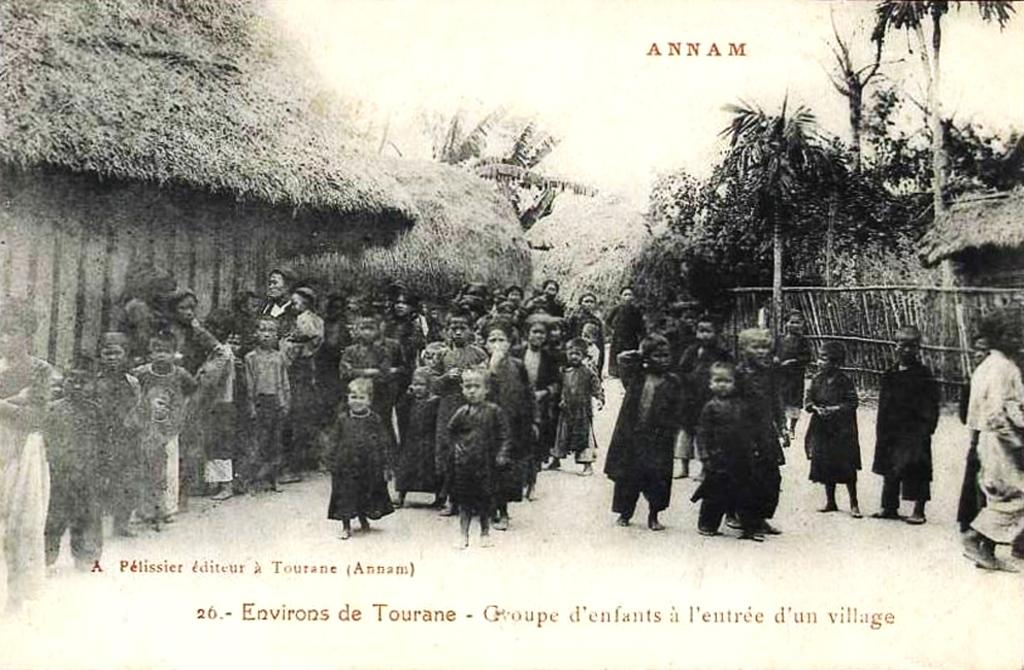Who or what can be seen in the image? There are people in the image. What type of structures are present in the image? There are huts in the image. What type of natural environment is visible in the image? There are trees in the image. Is there any text visible in the image? Yes, there is some text visible in the image. What type of calendar is visible in the image? There is no calendar present in the image. 